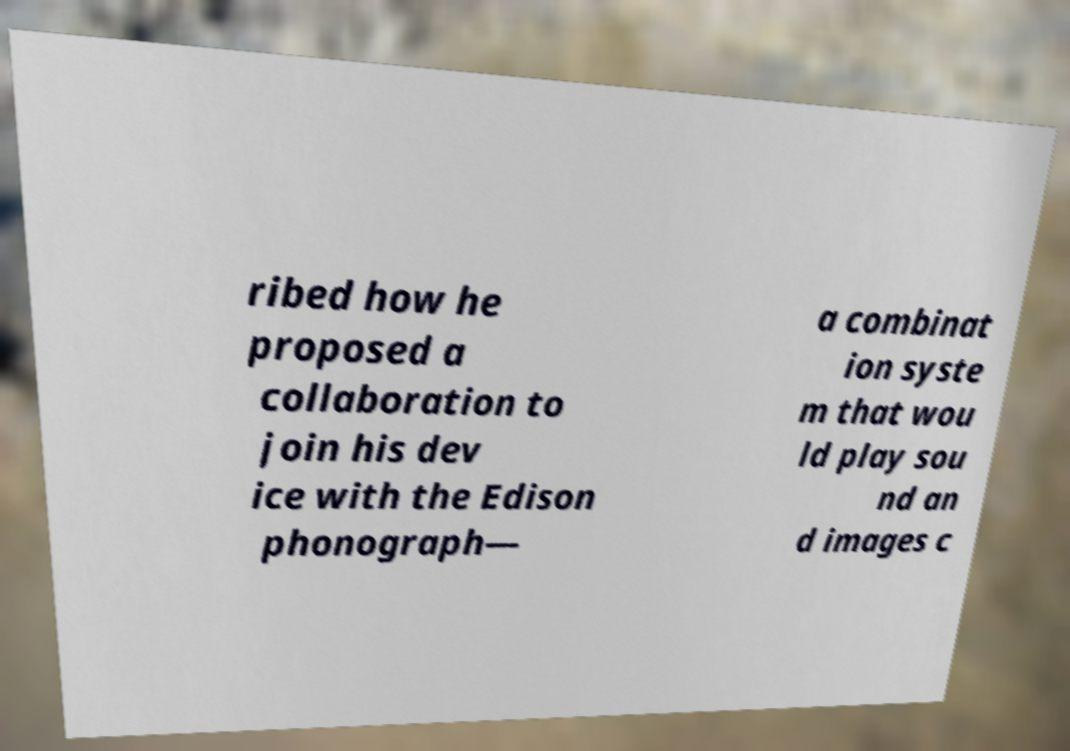Please read and relay the text visible in this image. What does it say? ribed how he proposed a collaboration to join his dev ice with the Edison phonograph— a combinat ion syste m that wou ld play sou nd an d images c 